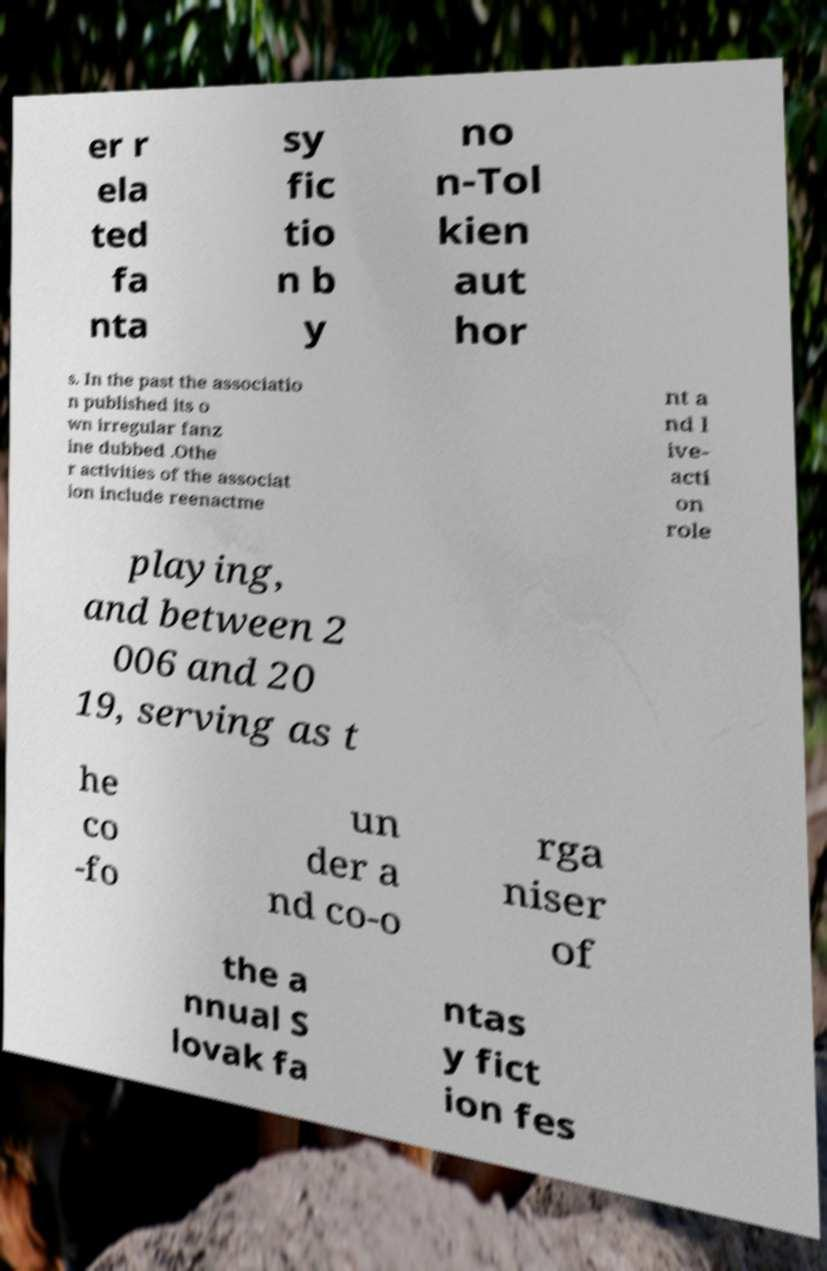Can you accurately transcribe the text from the provided image for me? er r ela ted fa nta sy fic tio n b y no n-Tol kien aut hor s. In the past the associatio n published its o wn irregular fanz ine dubbed .Othe r activities of the associat ion include reenactme nt a nd l ive- acti on role playing, and between 2 006 and 20 19, serving as t he co -fo un der a nd co-o rga niser of the a nnual S lovak fa ntas y fict ion fes 